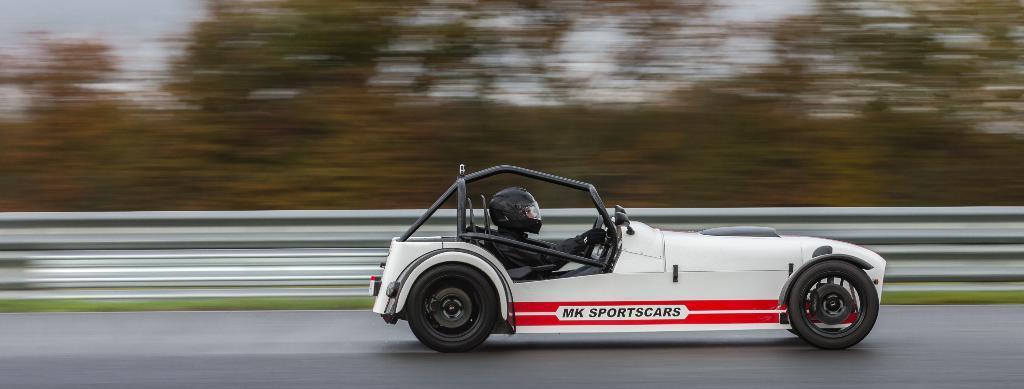In one or two sentences, can you explain what this image depicts? There is a person sitting and riding a car on the road and wore helmet. Background it is blurry and we can see sky and trees. 